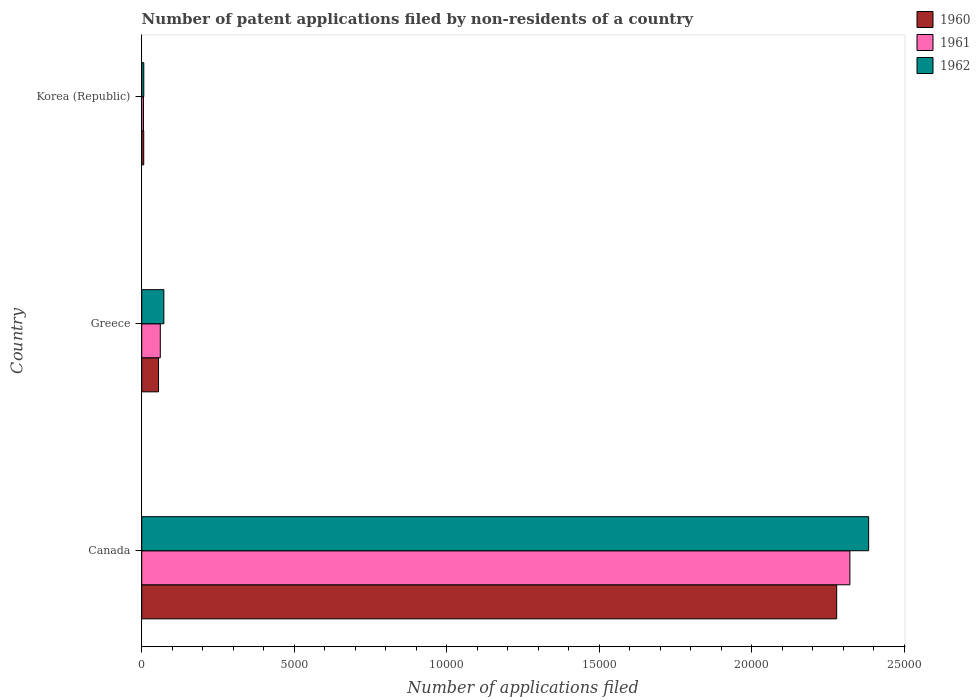How many different coloured bars are there?
Offer a terse response. 3. Are the number of bars per tick equal to the number of legend labels?
Provide a succinct answer. Yes. How many bars are there on the 2nd tick from the top?
Offer a very short reply. 3. What is the label of the 3rd group of bars from the top?
Make the answer very short. Canada. What is the number of applications filed in 1962 in Korea (Republic)?
Your response must be concise. 68. Across all countries, what is the maximum number of applications filed in 1961?
Your answer should be compact. 2.32e+04. What is the total number of applications filed in 1960 in the graph?
Your response must be concise. 2.34e+04. What is the difference between the number of applications filed in 1961 in Greece and that in Korea (Republic)?
Offer a very short reply. 551. What is the difference between the number of applications filed in 1960 in Greece and the number of applications filed in 1962 in Canada?
Your answer should be very brief. -2.33e+04. What is the average number of applications filed in 1962 per country?
Offer a terse response. 8209.33. What is the difference between the number of applications filed in 1962 and number of applications filed in 1961 in Greece?
Provide a succinct answer. 117. In how many countries, is the number of applications filed in 1962 greater than 4000 ?
Offer a terse response. 1. What is the ratio of the number of applications filed in 1962 in Canada to that in Greece?
Ensure brevity in your answer.  32.83. Is the number of applications filed in 1960 in Canada less than that in Greece?
Keep it short and to the point. No. What is the difference between the highest and the second highest number of applications filed in 1960?
Provide a succinct answer. 2.22e+04. What is the difference between the highest and the lowest number of applications filed in 1960?
Your answer should be compact. 2.27e+04. In how many countries, is the number of applications filed in 1961 greater than the average number of applications filed in 1961 taken over all countries?
Ensure brevity in your answer.  1. Is the sum of the number of applications filed in 1960 in Greece and Korea (Republic) greater than the maximum number of applications filed in 1961 across all countries?
Your answer should be compact. No. How many countries are there in the graph?
Offer a terse response. 3. Are the values on the major ticks of X-axis written in scientific E-notation?
Offer a very short reply. No. Does the graph contain grids?
Your response must be concise. No. Where does the legend appear in the graph?
Give a very brief answer. Top right. How are the legend labels stacked?
Give a very brief answer. Vertical. What is the title of the graph?
Your answer should be compact. Number of patent applications filed by non-residents of a country. Does "1985" appear as one of the legend labels in the graph?
Your response must be concise. No. What is the label or title of the X-axis?
Provide a short and direct response. Number of applications filed. What is the label or title of the Y-axis?
Offer a very short reply. Country. What is the Number of applications filed of 1960 in Canada?
Your answer should be very brief. 2.28e+04. What is the Number of applications filed in 1961 in Canada?
Offer a terse response. 2.32e+04. What is the Number of applications filed of 1962 in Canada?
Your response must be concise. 2.38e+04. What is the Number of applications filed of 1960 in Greece?
Give a very brief answer. 551. What is the Number of applications filed in 1961 in Greece?
Ensure brevity in your answer.  609. What is the Number of applications filed in 1962 in Greece?
Your answer should be very brief. 726. Across all countries, what is the maximum Number of applications filed in 1960?
Make the answer very short. 2.28e+04. Across all countries, what is the maximum Number of applications filed in 1961?
Offer a very short reply. 2.32e+04. Across all countries, what is the maximum Number of applications filed in 1962?
Offer a terse response. 2.38e+04. Across all countries, what is the minimum Number of applications filed of 1960?
Your answer should be compact. 66. Across all countries, what is the minimum Number of applications filed of 1961?
Your response must be concise. 58. What is the total Number of applications filed in 1960 in the graph?
Offer a terse response. 2.34e+04. What is the total Number of applications filed of 1961 in the graph?
Your answer should be compact. 2.39e+04. What is the total Number of applications filed of 1962 in the graph?
Your response must be concise. 2.46e+04. What is the difference between the Number of applications filed of 1960 in Canada and that in Greece?
Ensure brevity in your answer.  2.22e+04. What is the difference between the Number of applications filed of 1961 in Canada and that in Greece?
Provide a short and direct response. 2.26e+04. What is the difference between the Number of applications filed in 1962 in Canada and that in Greece?
Offer a terse response. 2.31e+04. What is the difference between the Number of applications filed in 1960 in Canada and that in Korea (Republic)?
Give a very brief answer. 2.27e+04. What is the difference between the Number of applications filed of 1961 in Canada and that in Korea (Republic)?
Keep it short and to the point. 2.32e+04. What is the difference between the Number of applications filed in 1962 in Canada and that in Korea (Republic)?
Your answer should be very brief. 2.38e+04. What is the difference between the Number of applications filed of 1960 in Greece and that in Korea (Republic)?
Provide a succinct answer. 485. What is the difference between the Number of applications filed of 1961 in Greece and that in Korea (Republic)?
Offer a terse response. 551. What is the difference between the Number of applications filed in 1962 in Greece and that in Korea (Republic)?
Provide a succinct answer. 658. What is the difference between the Number of applications filed of 1960 in Canada and the Number of applications filed of 1961 in Greece?
Your answer should be very brief. 2.22e+04. What is the difference between the Number of applications filed of 1960 in Canada and the Number of applications filed of 1962 in Greece?
Offer a very short reply. 2.21e+04. What is the difference between the Number of applications filed of 1961 in Canada and the Number of applications filed of 1962 in Greece?
Provide a short and direct response. 2.25e+04. What is the difference between the Number of applications filed of 1960 in Canada and the Number of applications filed of 1961 in Korea (Republic)?
Keep it short and to the point. 2.27e+04. What is the difference between the Number of applications filed of 1960 in Canada and the Number of applications filed of 1962 in Korea (Republic)?
Provide a short and direct response. 2.27e+04. What is the difference between the Number of applications filed in 1961 in Canada and the Number of applications filed in 1962 in Korea (Republic)?
Make the answer very short. 2.32e+04. What is the difference between the Number of applications filed of 1960 in Greece and the Number of applications filed of 1961 in Korea (Republic)?
Offer a very short reply. 493. What is the difference between the Number of applications filed in 1960 in Greece and the Number of applications filed in 1962 in Korea (Republic)?
Ensure brevity in your answer.  483. What is the difference between the Number of applications filed in 1961 in Greece and the Number of applications filed in 1962 in Korea (Republic)?
Provide a short and direct response. 541. What is the average Number of applications filed of 1960 per country?
Provide a short and direct response. 7801. What is the average Number of applications filed in 1961 per country?
Offer a very short reply. 7962. What is the average Number of applications filed of 1962 per country?
Your response must be concise. 8209.33. What is the difference between the Number of applications filed of 1960 and Number of applications filed of 1961 in Canada?
Make the answer very short. -433. What is the difference between the Number of applications filed in 1960 and Number of applications filed in 1962 in Canada?
Provide a succinct answer. -1048. What is the difference between the Number of applications filed of 1961 and Number of applications filed of 1962 in Canada?
Your answer should be very brief. -615. What is the difference between the Number of applications filed of 1960 and Number of applications filed of 1961 in Greece?
Provide a succinct answer. -58. What is the difference between the Number of applications filed of 1960 and Number of applications filed of 1962 in Greece?
Make the answer very short. -175. What is the difference between the Number of applications filed of 1961 and Number of applications filed of 1962 in Greece?
Provide a short and direct response. -117. What is the difference between the Number of applications filed of 1960 and Number of applications filed of 1961 in Korea (Republic)?
Offer a terse response. 8. What is the difference between the Number of applications filed of 1961 and Number of applications filed of 1962 in Korea (Republic)?
Provide a succinct answer. -10. What is the ratio of the Number of applications filed in 1960 in Canada to that in Greece?
Provide a short and direct response. 41.35. What is the ratio of the Number of applications filed in 1961 in Canada to that in Greece?
Provide a short and direct response. 38.13. What is the ratio of the Number of applications filed in 1962 in Canada to that in Greece?
Provide a succinct answer. 32.83. What is the ratio of the Number of applications filed in 1960 in Canada to that in Korea (Republic)?
Your answer should be compact. 345.24. What is the ratio of the Number of applications filed of 1961 in Canada to that in Korea (Republic)?
Provide a succinct answer. 400.33. What is the ratio of the Number of applications filed in 1962 in Canada to that in Korea (Republic)?
Provide a succinct answer. 350.5. What is the ratio of the Number of applications filed in 1960 in Greece to that in Korea (Republic)?
Make the answer very short. 8.35. What is the ratio of the Number of applications filed in 1962 in Greece to that in Korea (Republic)?
Your answer should be compact. 10.68. What is the difference between the highest and the second highest Number of applications filed in 1960?
Offer a very short reply. 2.22e+04. What is the difference between the highest and the second highest Number of applications filed of 1961?
Keep it short and to the point. 2.26e+04. What is the difference between the highest and the second highest Number of applications filed of 1962?
Give a very brief answer. 2.31e+04. What is the difference between the highest and the lowest Number of applications filed of 1960?
Give a very brief answer. 2.27e+04. What is the difference between the highest and the lowest Number of applications filed in 1961?
Provide a short and direct response. 2.32e+04. What is the difference between the highest and the lowest Number of applications filed of 1962?
Your answer should be compact. 2.38e+04. 